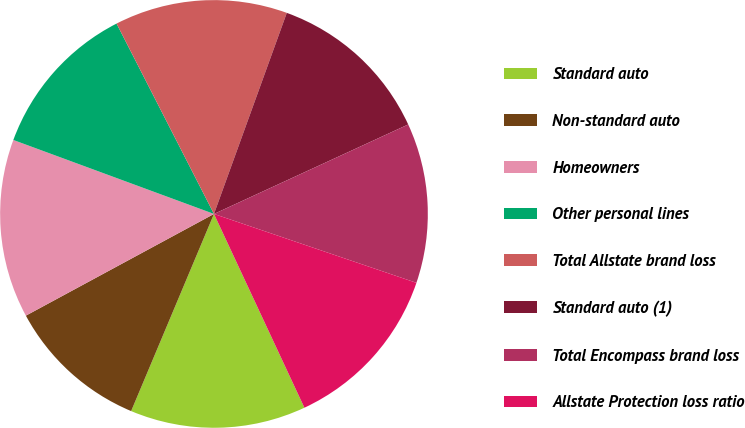<chart> <loc_0><loc_0><loc_500><loc_500><pie_chart><fcel>Standard auto<fcel>Non-standard auto<fcel>Homeowners<fcel>Other personal lines<fcel>Total Allstate brand loss<fcel>Standard auto (1)<fcel>Total Encompass brand loss<fcel>Allstate Protection loss ratio<nl><fcel>13.28%<fcel>10.78%<fcel>13.51%<fcel>11.85%<fcel>13.06%<fcel>12.6%<fcel>12.09%<fcel>12.83%<nl></chart> 